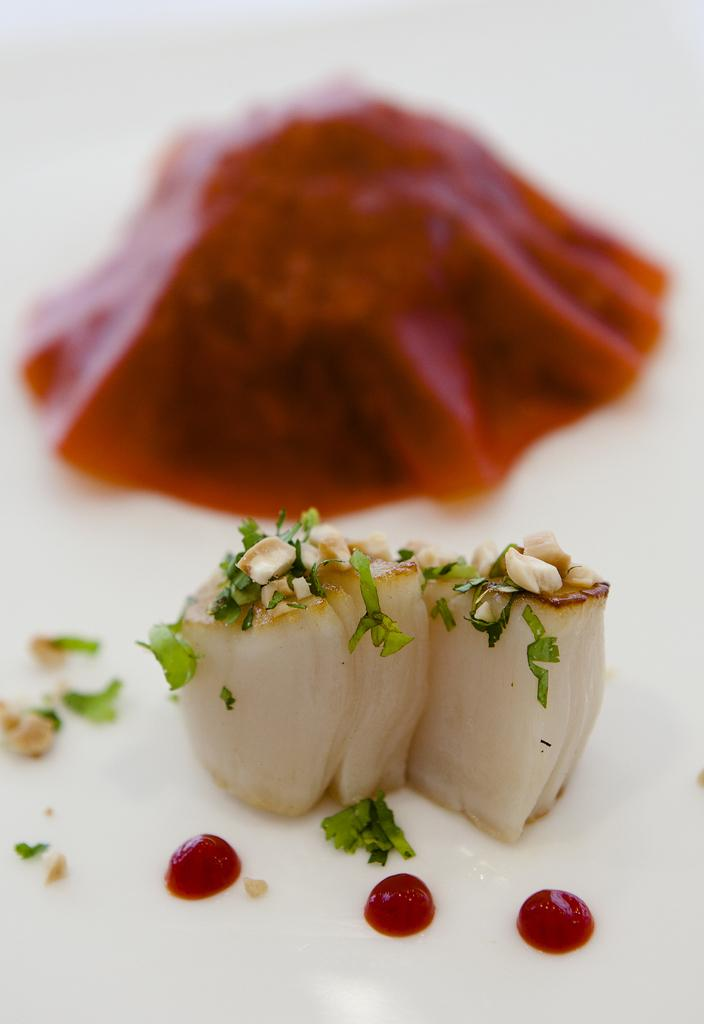What is the main subject in the foreground of the image? There is a food item in the foreground of the image. What can be seen in the background of the image? There is water visible in the image. What type of school can be seen in the image? There is no school present in the image. Can you tell me the answer to the question that is not visible in the image? There is no question or answer present in the image. 